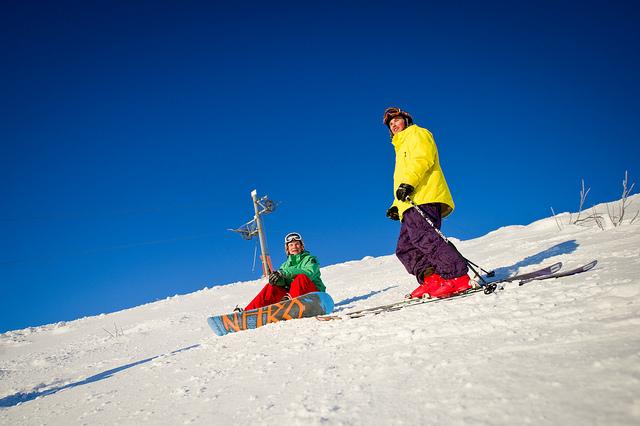What is in the man's hands?
Keep it brief. Ski poles. What is written on the bottom of the board?
Keep it brief. Nitro. Is it daytime?
Short answer required. Yes. 